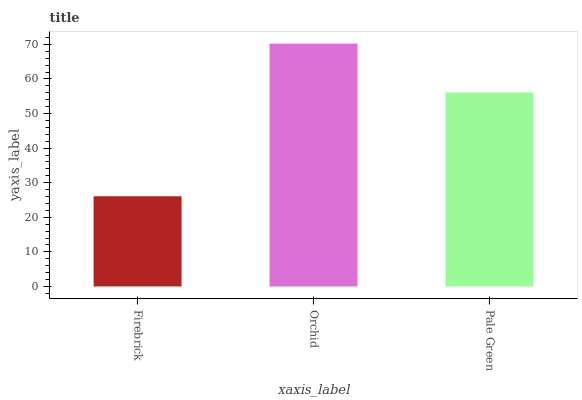Is Firebrick the minimum?
Answer yes or no. Yes. Is Orchid the maximum?
Answer yes or no. Yes. Is Pale Green the minimum?
Answer yes or no. No. Is Pale Green the maximum?
Answer yes or no. No. Is Orchid greater than Pale Green?
Answer yes or no. Yes. Is Pale Green less than Orchid?
Answer yes or no. Yes. Is Pale Green greater than Orchid?
Answer yes or no. No. Is Orchid less than Pale Green?
Answer yes or no. No. Is Pale Green the high median?
Answer yes or no. Yes. Is Pale Green the low median?
Answer yes or no. Yes. Is Firebrick the high median?
Answer yes or no. No. Is Firebrick the low median?
Answer yes or no. No. 